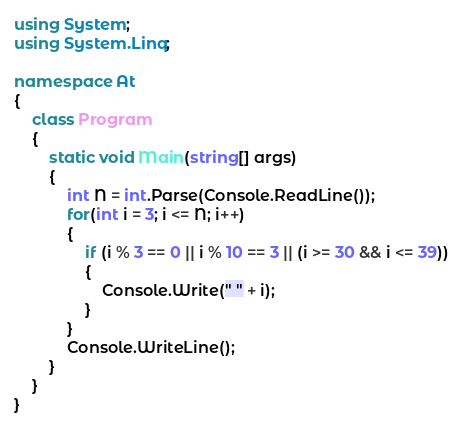Convert code to text. <code><loc_0><loc_0><loc_500><loc_500><_C#_>using System;
using System.Linq;

namespace At
{
    class Program
    {
        static void Main(string[] args)
        {
            int N = int.Parse(Console.ReadLine());
            for(int i = 3; i <= N; i++)
            {
                if (i % 3 == 0 || i % 10 == 3 || (i >= 30 && i <= 39))
                {
                    Console.Write(" " + i);
                }
            }
            Console.WriteLine();
        }
    }
}</code> 